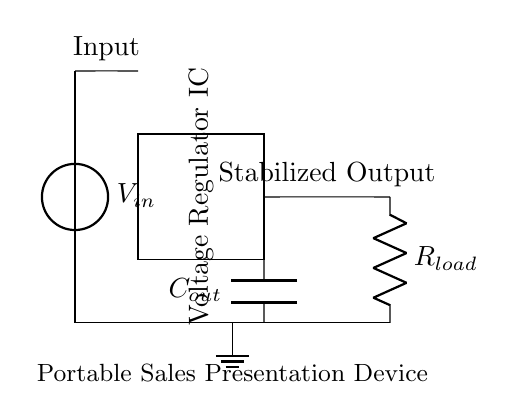What is the type of the voltage regulator used in the circuit? The diagram shows a rectangle labeled "Voltage Regulator IC," indicating that an integrated circuit type is used for voltage regulation.
Answer: Voltage Regulator IC What component stabilizes the output voltage? The "Voltage Regulator IC" is shown in the diagram, which regulates and stabilizes the output voltage for the connected load.
Answer: Voltage Regulator IC What is connected to the output of the voltage regulator? The output of the voltage regulator connects to a load, indicated by a resistor labeled "R_load" in the diagram.
Answer: R_load How many capacitors are present in the circuit? The circuit diagram features one capacitor labeled "C_out," which is placed at the output of the voltage regulator.
Answer: 1 What is the function of C_out in the circuit? The capacitor "C_out" is typically used for filtering the output, providing stability by reducing voltage ripple across the load.
Answer: Filtering What is the role of the input voltage source? The input voltage source "V_in" provides the necessary voltage supply to the voltage regulator for operation, and the regulator outputs a stabilized voltage.
Answer: Supply voltage What does the ground represent in the circuit? The ground symbolizes the common reference potential for the circuit, ensuring proper operation and stability by providing a return path for current.
Answer: Common reference 